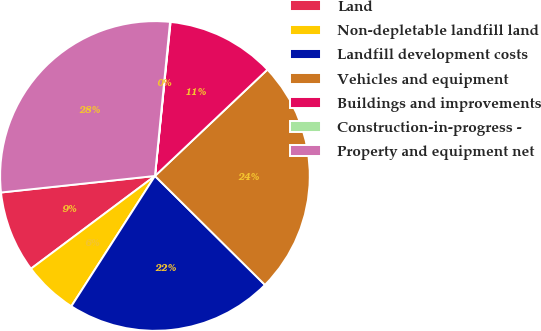<chart> <loc_0><loc_0><loc_500><loc_500><pie_chart><fcel>Land<fcel>Non-depletable landfill land<fcel>Landfill development costs<fcel>Vehicles and equipment<fcel>Buildings and improvements<fcel>Construction-in-progress -<fcel>Property and equipment net<nl><fcel>8.52%<fcel>5.7%<fcel>21.66%<fcel>24.48%<fcel>11.34%<fcel>0.05%<fcel>28.26%<nl></chart> 